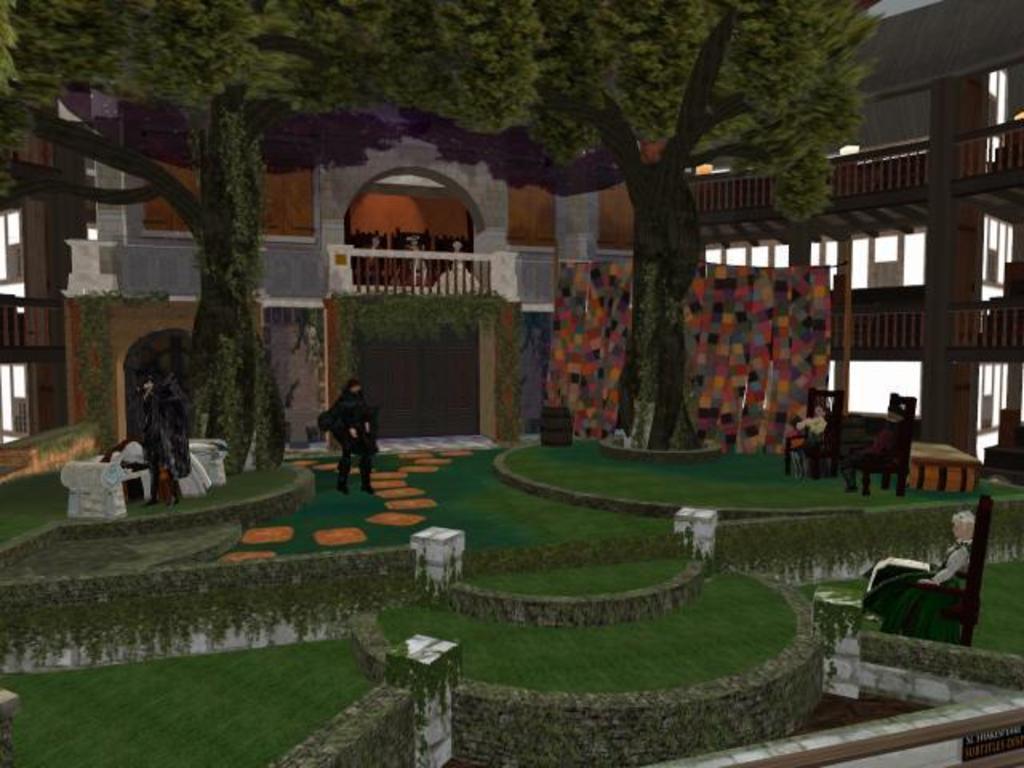In one or two sentences, can you explain what this image depicts? This is an animated picture, in this picture there are few trees, chairs, persons, walls and grass. In the background, we can see a building. 